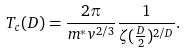<formula> <loc_0><loc_0><loc_500><loc_500>T _ { c } ( D ) = \frac { 2 \pi } { m ^ { \ast } v ^ { 2 / 3 } } \frac { 1 } { \zeta ( \frac { D } { 2 } ) ^ { 2 / D } } .</formula> 